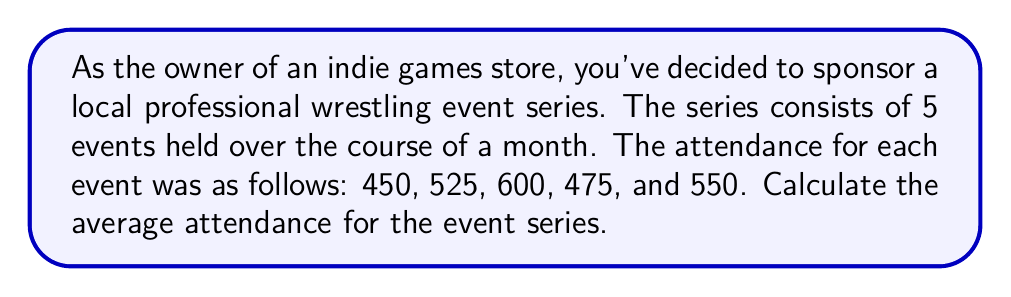Could you help me with this problem? To calculate the average attendance for the wrestling event series, we need to follow these steps:

1. Sum up the total attendance for all events:
   $450 + 525 + 600 + 475 + 550 = 2600$

2. Count the number of events:
   There are 5 events in total.

3. Calculate the average by dividing the total attendance by the number of events:
   $\text{Average} = \frac{\text{Total Attendance}}{\text{Number of Events}}$

   $\text{Average} = \frac{2600}{5}$

4. Perform the division:
   $\text{Average} = 520$

Therefore, the average attendance for the wrestling event series is 520 people per event.
Answer: $520$ people 